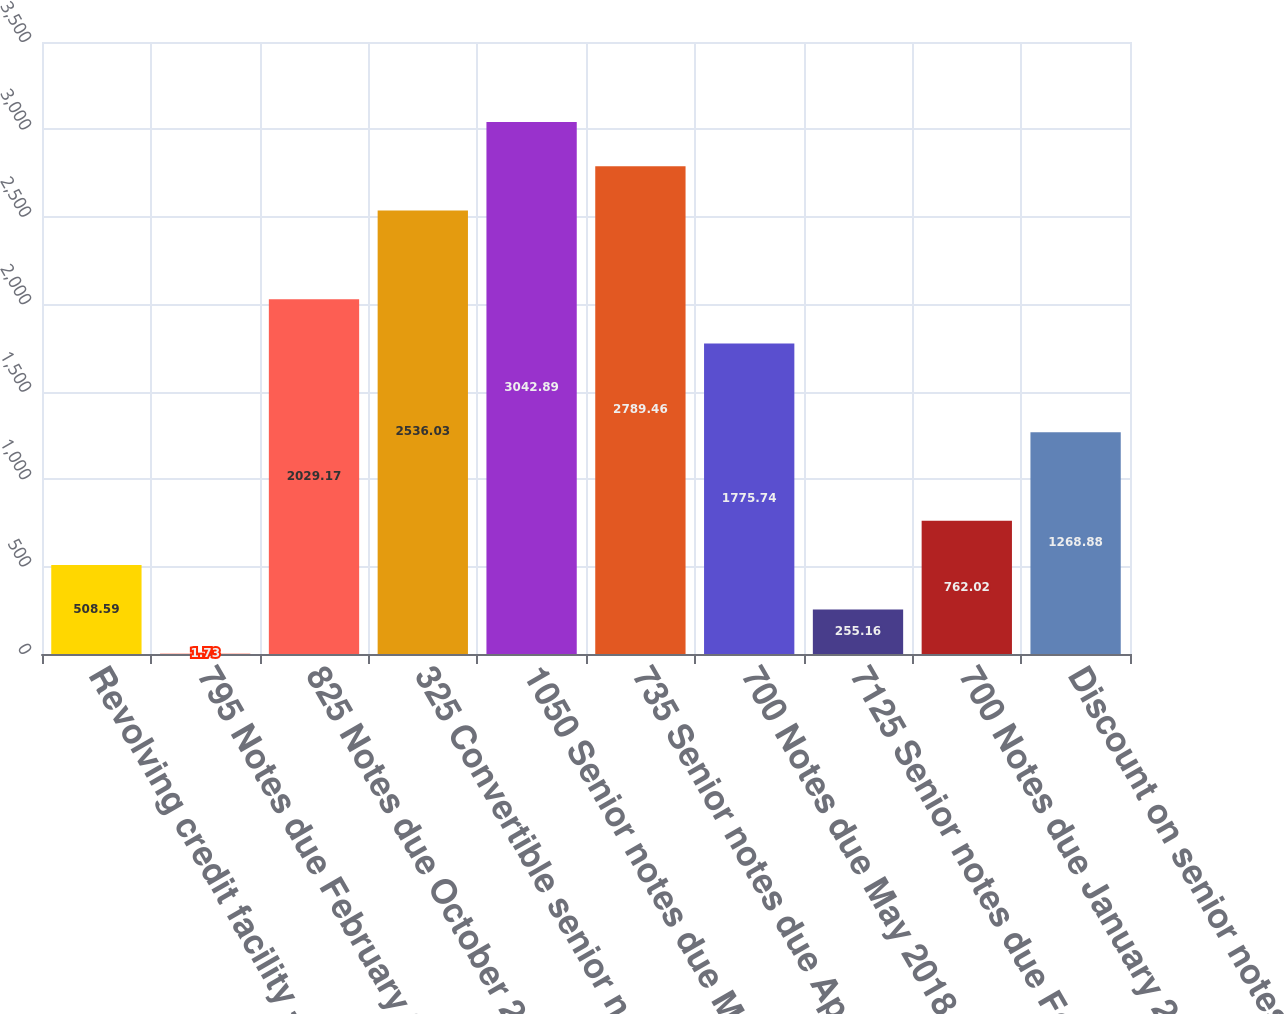<chart> <loc_0><loc_0><loc_500><loc_500><bar_chart><fcel>Revolving credit facility -<fcel>795 Notes due February 2010<fcel>825 Notes due October 2011<fcel>325 Convertible senior notes<fcel>1050 Senior notes due March<fcel>735 Senior notes due April<fcel>700 Notes due May 2018<fcel>7125 Senior notes due February<fcel>700 Notes due January 2028<fcel>Discount on senior notes<nl><fcel>508.59<fcel>1.73<fcel>2029.17<fcel>2536.03<fcel>3042.89<fcel>2789.46<fcel>1775.74<fcel>255.16<fcel>762.02<fcel>1268.88<nl></chart> 